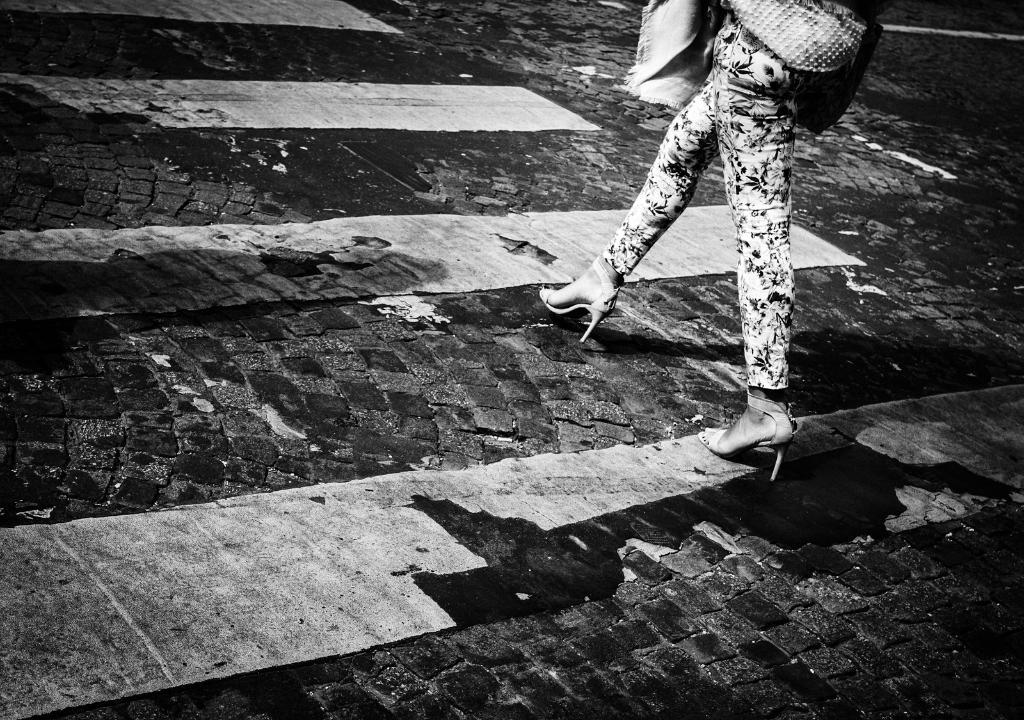What is happening in the image? There is a person in the image, and they are walking on the road. road. What can be seen on the road in the image? There are lines visible in the image. What type of potato is the person holding in the image? There is no potato present in the image; the person is walking on the road. What is the condition of the roof in the image? There is no roof present in the image; it is focused on a person walking on the road. 